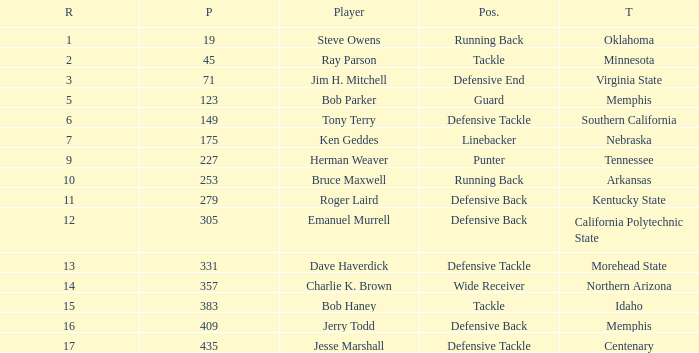What is the lowest pick of the defensive tackle player dave haverdick? 331.0. Give me the full table as a dictionary. {'header': ['R', 'P', 'Player', 'Pos.', 'T'], 'rows': [['1', '19', 'Steve Owens', 'Running Back', 'Oklahoma'], ['2', '45', 'Ray Parson', 'Tackle', 'Minnesota'], ['3', '71', 'Jim H. Mitchell', 'Defensive End', 'Virginia State'], ['5', '123', 'Bob Parker', 'Guard', 'Memphis'], ['6', '149', 'Tony Terry', 'Defensive Tackle', 'Southern California'], ['7', '175', 'Ken Geddes', 'Linebacker', 'Nebraska'], ['9', '227', 'Herman Weaver', 'Punter', 'Tennessee'], ['10', '253', 'Bruce Maxwell', 'Running Back', 'Arkansas'], ['11', '279', 'Roger Laird', 'Defensive Back', 'Kentucky State'], ['12', '305', 'Emanuel Murrell', 'Defensive Back', 'California Polytechnic State'], ['13', '331', 'Dave Haverdick', 'Defensive Tackle', 'Morehead State'], ['14', '357', 'Charlie K. Brown', 'Wide Receiver', 'Northern Arizona'], ['15', '383', 'Bob Haney', 'Tackle', 'Idaho'], ['16', '409', 'Jerry Todd', 'Defensive Back', 'Memphis'], ['17', '435', 'Jesse Marshall', 'Defensive Tackle', 'Centenary']]} 